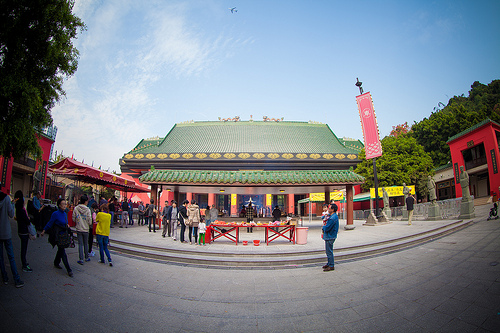<image>
Is there a man behind the road? No. The man is not behind the road. From this viewpoint, the man appears to be positioned elsewhere in the scene. 